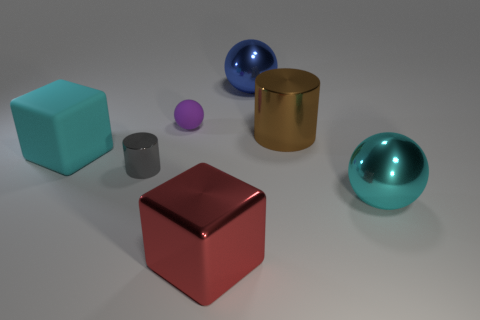Subtract all gray spheres. Subtract all cyan cubes. How many spheres are left? 3 Add 2 shiny cylinders. How many objects exist? 9 Subtract all cylinders. How many objects are left? 5 Subtract 0 brown cubes. How many objects are left? 7 Subtract all large metal balls. Subtract all small brown matte objects. How many objects are left? 5 Add 2 large blue metal spheres. How many large blue metal spheres are left? 3 Add 6 tiny cyan matte cylinders. How many tiny cyan matte cylinders exist? 6 